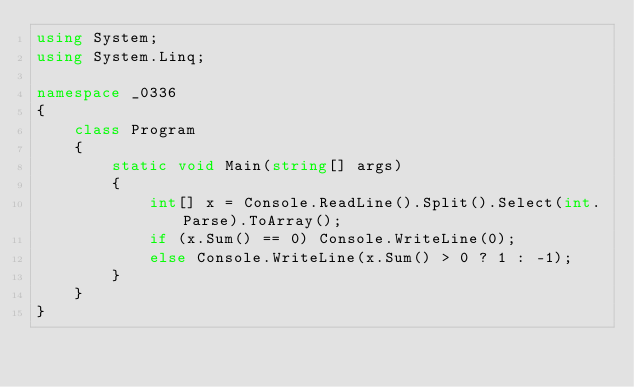<code> <loc_0><loc_0><loc_500><loc_500><_C#_>using System;
using System.Linq;

namespace _0336
{
    class Program
    {
        static void Main(string[] args)
        {
            int[] x = Console.ReadLine().Split().Select(int.Parse).ToArray();
            if (x.Sum() == 0) Console.WriteLine(0);
            else Console.WriteLine(x.Sum() > 0 ? 1 : -1);
        }
    }
}</code> 